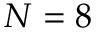<formula> <loc_0><loc_0><loc_500><loc_500>N = 8</formula> 